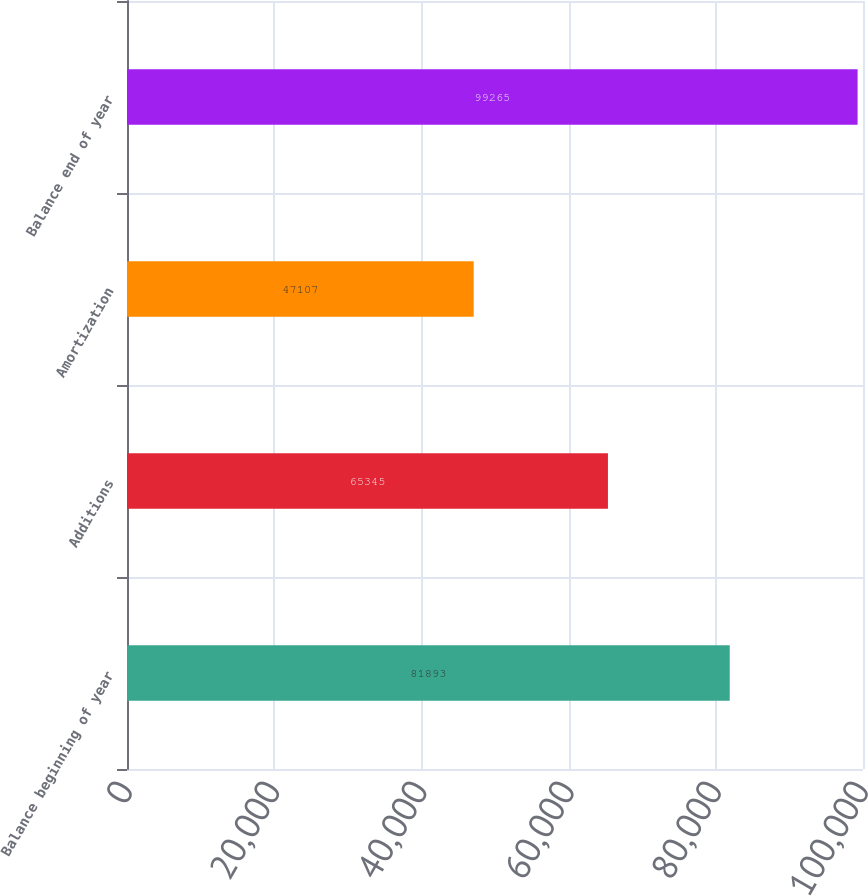Convert chart to OTSL. <chart><loc_0><loc_0><loc_500><loc_500><bar_chart><fcel>Balance beginning of year<fcel>Additions<fcel>Amortization<fcel>Balance end of year<nl><fcel>81893<fcel>65345<fcel>47107<fcel>99265<nl></chart> 